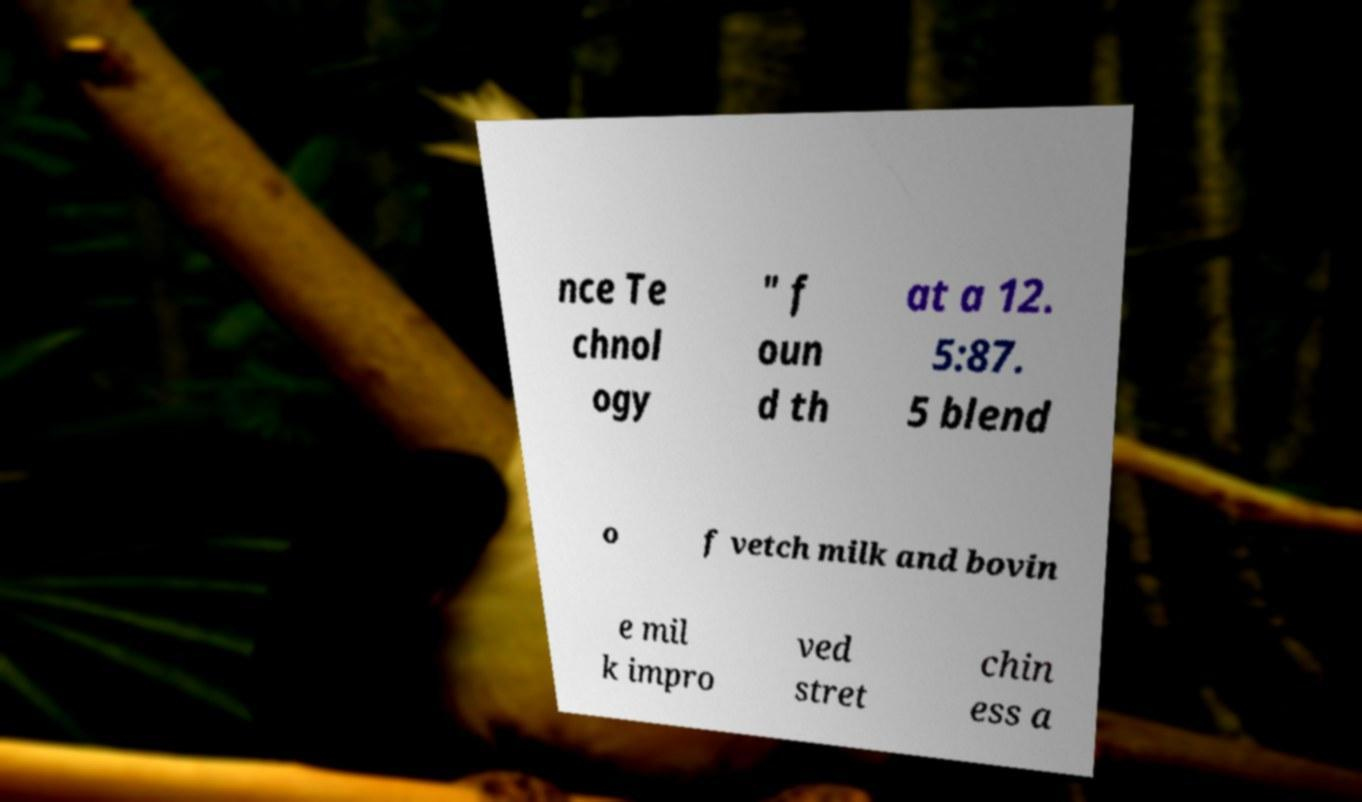Could you assist in decoding the text presented in this image and type it out clearly? nce Te chnol ogy " f oun d th at a 12. 5:87. 5 blend o f vetch milk and bovin e mil k impro ved stret chin ess a 